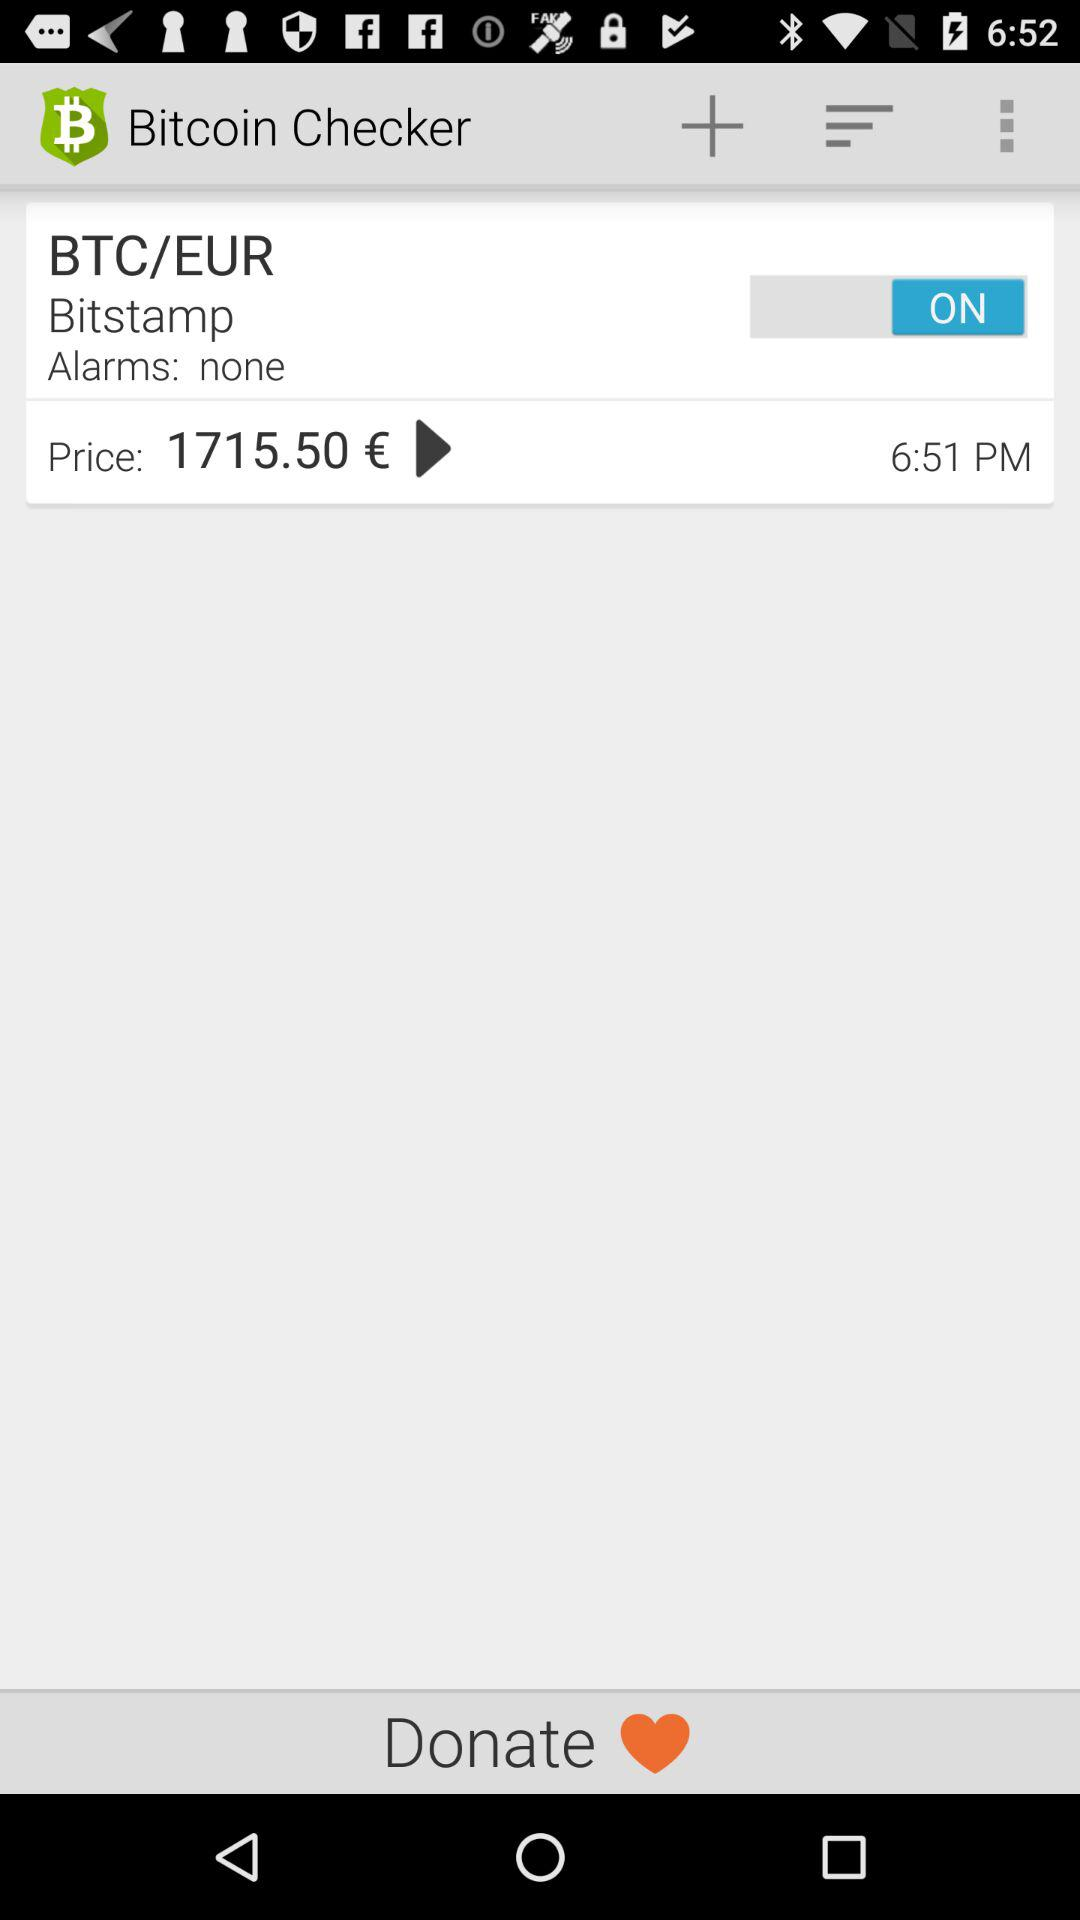What's the status of "BTC/EUR"? The status of "BTC/EUR" is "on". 